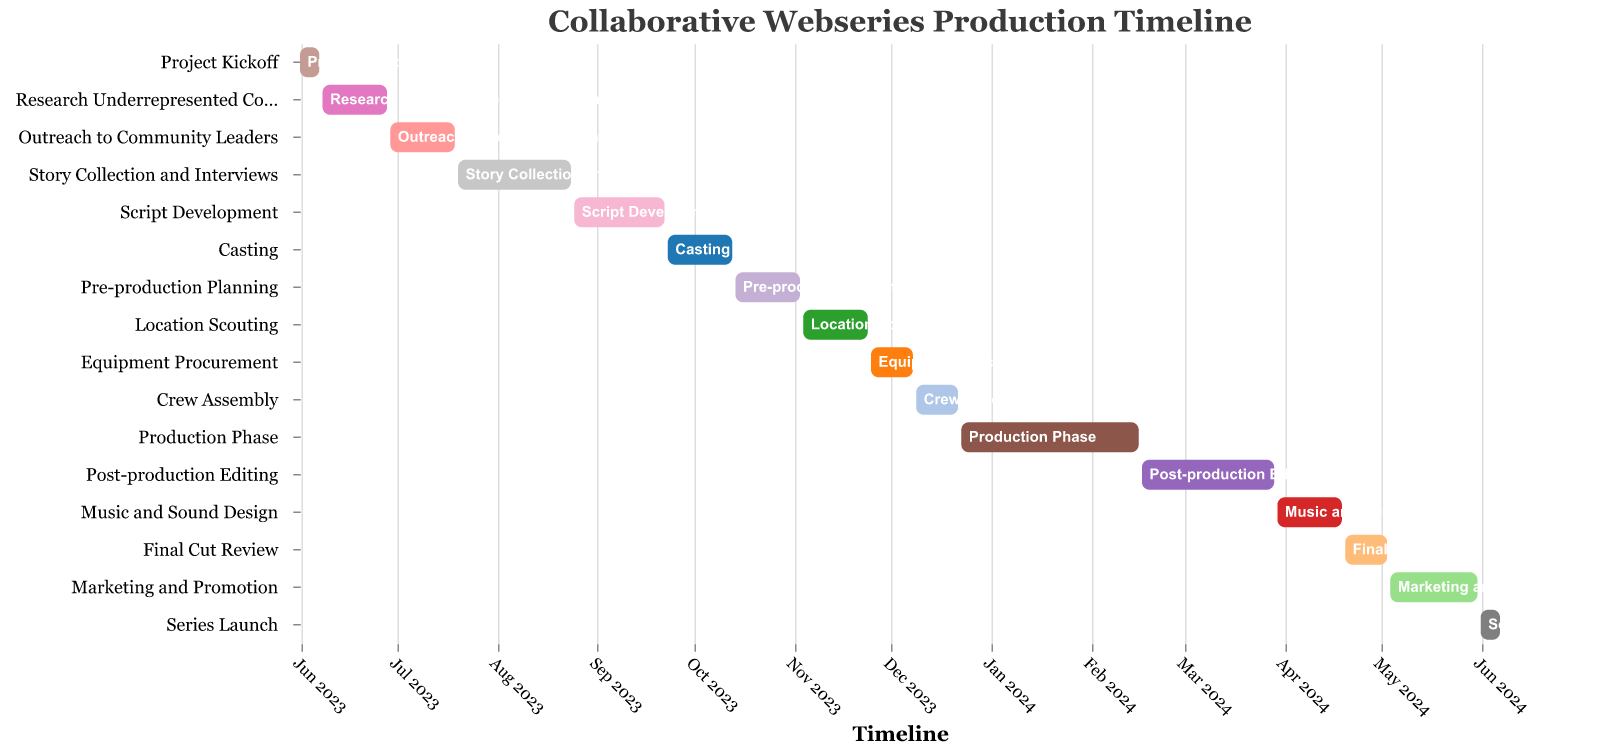What is the title of the figure? The title is displayed at the top of the Gantt Chart and is clearly visible.
Answer: Collaborative Webseries Production Timeline Which task has the longest duration? The duration for each task is displayed visually by the length of the bars. The "Production Phase" task has the longest bar.
Answer: Production Phase How many tasks are planned to be completed by the end of November 2023? Tasks scheduled to end on or before November 30, 2023, include tasks ending in June, July, August, September, October, and November. Count these tasks from the Gantt chart.
Answer: 8 When does the "Production Phase" start and end? The "Production Phase" bar shows the start and end dates. Follow it visually from the start to end points.
Answer: Starts on Dec 23, 2023, Ends on Feb 16, 2024 How long is the "Pre-production Planning" phase? The length of the "Pre-production Planning" bar indicates duration. It spans from Oct 14, 2023, to Nov 3, 2023. Calculating the days includes start and end dates.
Answer: 21 days Does the "Script Development" phase overlap with the "Casting" phase? Look at the dates for "Script Development" and "Casting" bars to see if they span the same period.
Answer: No Which activities take the same amount of time as "Outreach to Community Leaders"? The duration for "Outreach to Community Leaders" is 21 days. Compare this with other bars to find those with the same length.
Answer: "Research Underrepresented Communities", "Casting", "Pre-production Planning", "Location Scouting", and "Music and Sound Design" What activities are planned after "Post-production Editing" finishes? Look at the end date of "Post-production Editing" (Mar 29, 2024) and identify any bars starting after this date.
Answer: "Music and Sound Design", "Final Cut Review", "Marketing and Promotion", "Series Launch" Which activity follows immediately after "Crew Assembly"? Locate the end date of "Crew Assembly" and identify the next task starting right after it.
Answer: Production Phase What is the total duration from the start of "Project Kickoff" to the end of "Series Launch"? Identify the start date of "Project Kickoff" and the end date of "Series Launch", and calculate the total duration.
Answer: 373 days 